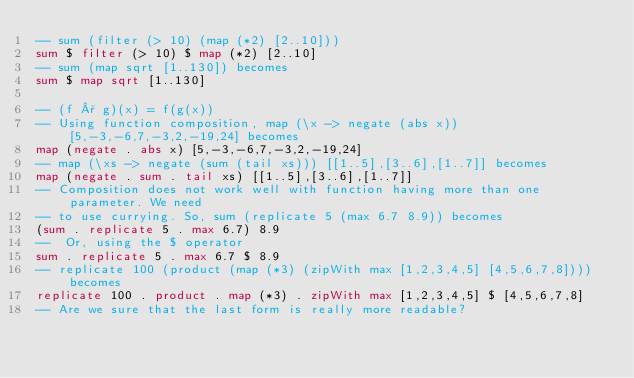<code> <loc_0><loc_0><loc_500><loc_500><_Haskell_>-- sum (filter (> 10) (map (*2) [2..10]))
sum $ filter (> 10) $ map (*2) [2..10]
-- sum (map sqrt [1..130]) becomes
sum $ map sqrt [1..130]

-- (f ° g)(x) = f(g(x))
-- Using function composition, map (\x -> negate (abs x)) [5,-3,-6,7,-3,2,-19,24] becomes
map (negate . abs x) [5,-3,-6,7,-3,2,-19,24]
-- map (\xs -> negate (sum (tail xs))) [[1..5],[3..6],[1..7]] becomes
map (negate . sum . tail xs) [[1..5],[3..6],[1..7]]
-- Composition does not work well with function having more than one parameter. We need 
-- to use currying. So, sum (replicate 5 (max 6.7 8.9)) becomes
(sum . replicate 5 . max 6.7) 8.9
--  Or, using the $ operator
sum . replicate 5 . max 6.7 $ 8.9
-- replicate 100 (product (map (*3) (zipWith max [1,2,3,4,5] [4,5,6,7,8]))) becomes
replicate 100 . product . map (*3) . zipWith max [1,2,3,4,5] $ [4,5,6,7,8]
-- Are we sure that the last form is really more readable?</code> 